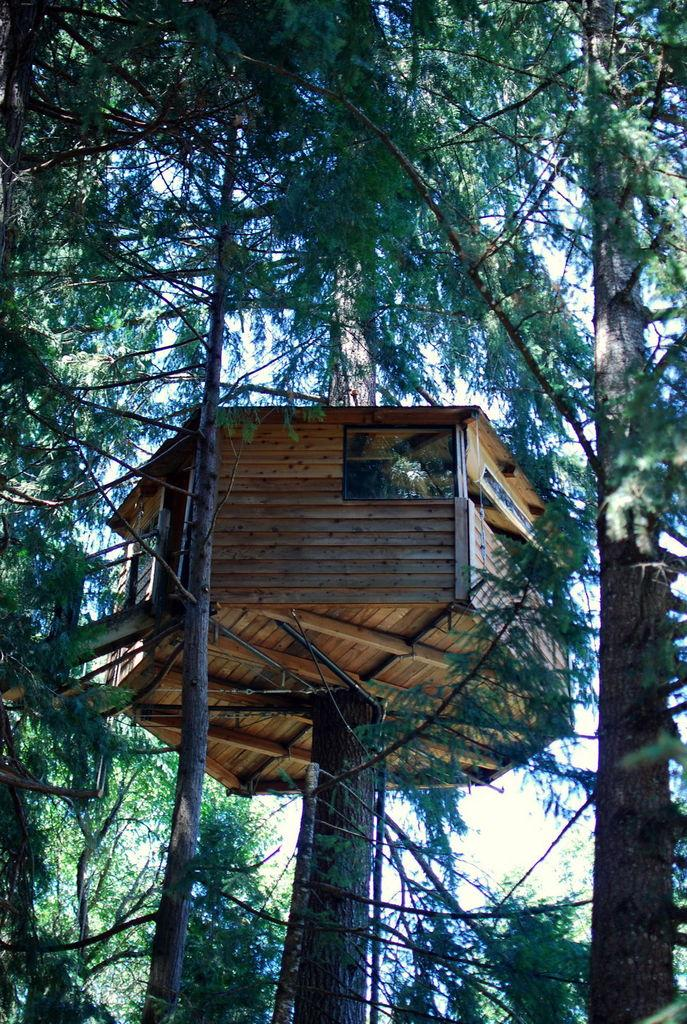What type of structure is visible in the image? There is a wooden tree house in the image. What can be seen in the background of the image? There are trees and the sky visible in the background of the image. What type of weather is indicated by the presence of sleet in the image? There is no mention of sleet in the image; it only shows a wooden tree house, trees, and the sky. 